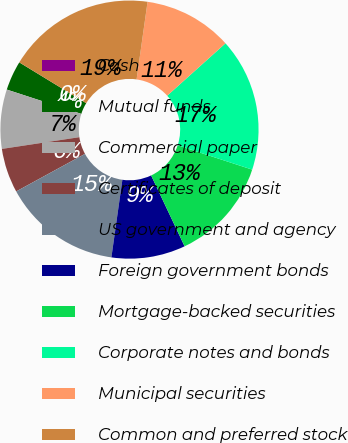<chart> <loc_0><loc_0><loc_500><loc_500><pie_chart><fcel>Cash<fcel>Mutual funds<fcel>Commercial paper<fcel>Certificates of deposit<fcel>US government and agency<fcel>Foreign government bonds<fcel>Mortgage-backed securities<fcel>Corporate notes and bonds<fcel>Municipal securities<fcel>Common and preferred stock<nl><fcel>0.0%<fcel>3.7%<fcel>7.41%<fcel>5.56%<fcel>14.81%<fcel>9.26%<fcel>12.96%<fcel>16.67%<fcel>11.11%<fcel>18.52%<nl></chart> 